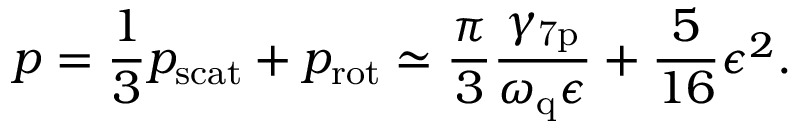Convert formula to latex. <formula><loc_0><loc_0><loc_500><loc_500>p = \frac { 1 } { 3 } p _ { s c a t } + p _ { r o t } \simeq \frac { \pi } { 3 } \frac { \gamma _ { 7 p } } { \omega _ { q } \epsilon } + \frac { 5 } { 1 6 } \epsilon ^ { 2 } .</formula> 